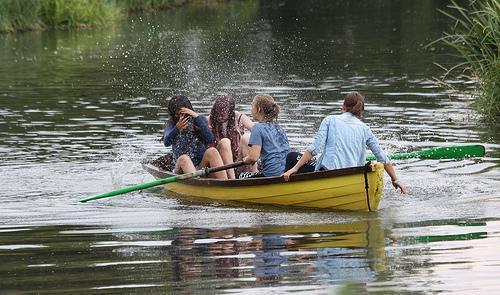How many girls are there?
Give a very brief answer. 4. 